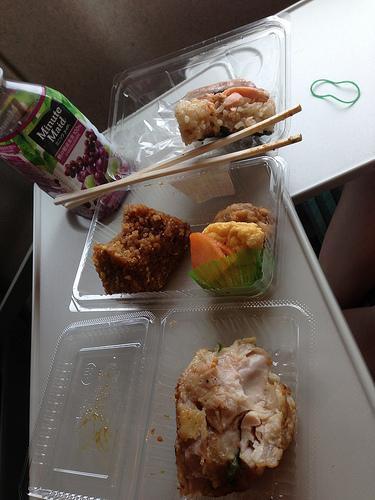How many drinks were there?
Give a very brief answer. 1. 